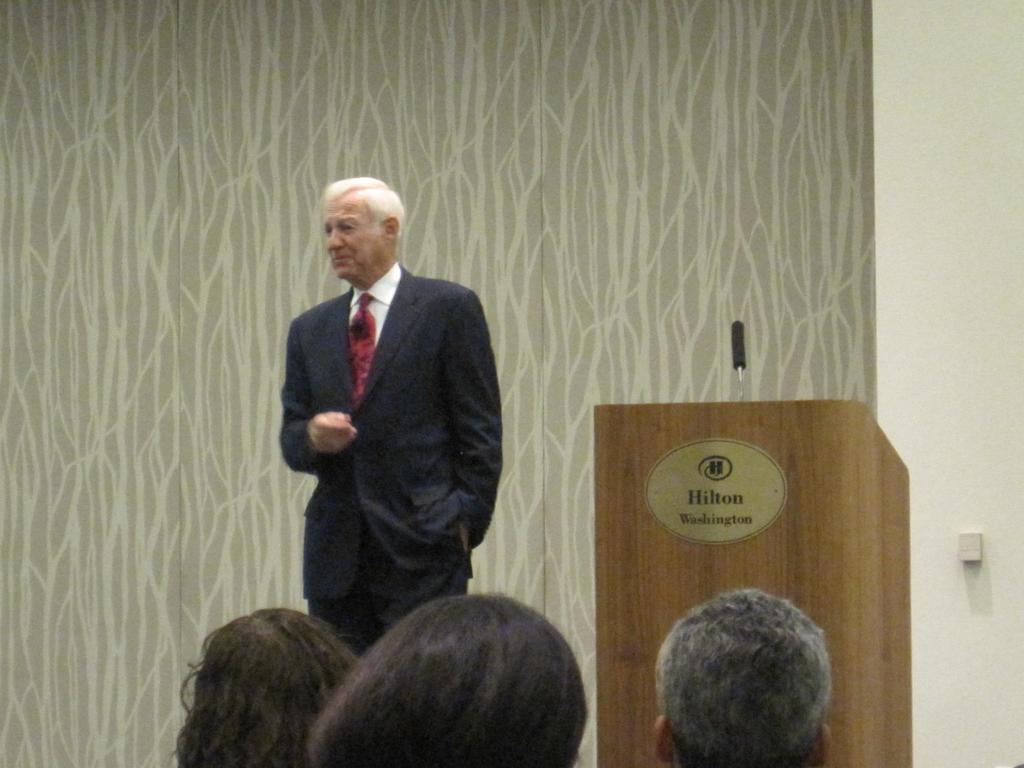How many people are in the image? There are people in the image, but the exact number is not specified. What is the person standing beside doing? The person standing beside a podium is likely preparing to speak or is already speaking. What is on the podium? There is a microphone on the podium. What can be seen in the background of the image? There is a wall in the background of the image. What color is the mitten that the person is wearing in the image? There is no mention of a mitten in the image, so it cannot be determined if a mitten is present or its color. 